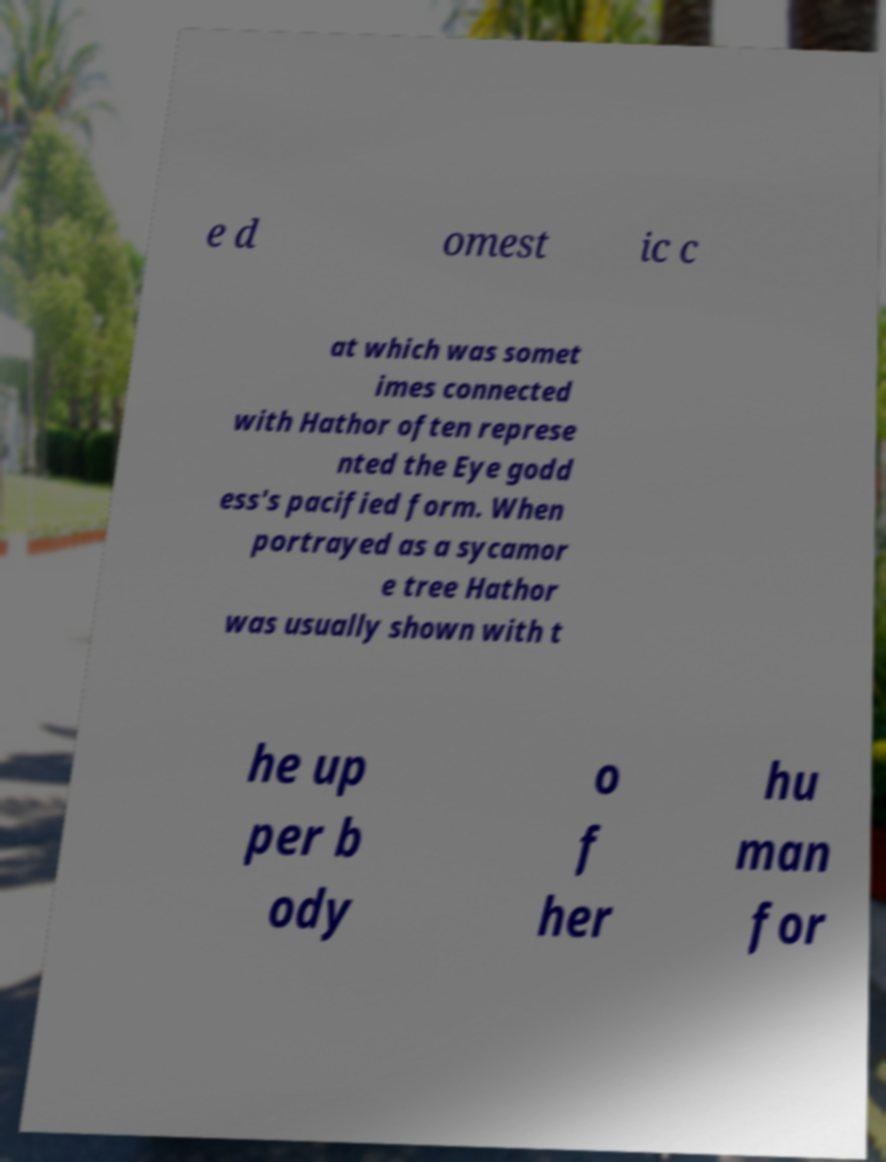Please identify and transcribe the text found in this image. e d omest ic c at which was somet imes connected with Hathor often represe nted the Eye godd ess's pacified form. When portrayed as a sycamor e tree Hathor was usually shown with t he up per b ody o f her hu man for 